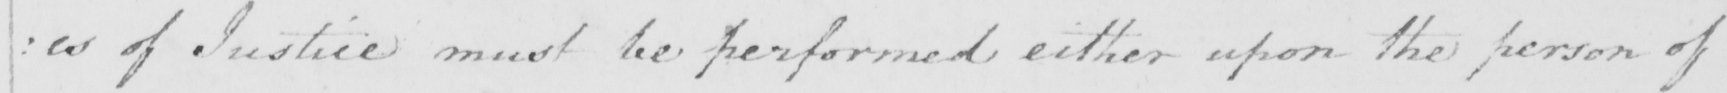Please provide the text content of this handwritten line. : es of Justice must be performed either upon the person of 